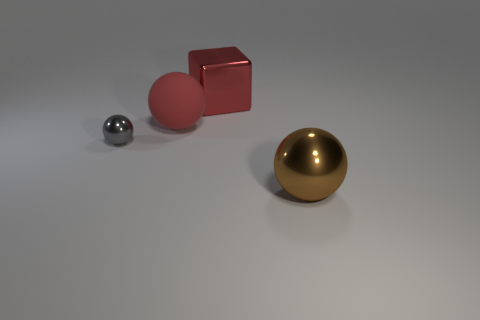Add 3 big red matte balls. How many objects exist? 7 Subtract all spheres. How many objects are left? 1 Add 3 big matte things. How many big matte things exist? 4 Subtract 0 purple spheres. How many objects are left? 4 Subtract all small gray metallic objects. Subtract all red cubes. How many objects are left? 2 Add 4 big red metallic cubes. How many big red metallic cubes are left? 5 